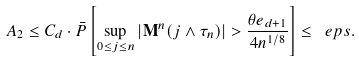Convert formula to latex. <formula><loc_0><loc_0><loc_500><loc_500>A _ { 2 } \leq C _ { d } \cdot \bar { P } \left [ \sup _ { 0 \leq j \leq n } | \mathbf M ^ { n } ( j \wedge \tau _ { n } ) | > \frac { \theta e _ { d + 1 } } { 4 n ^ { 1 / 8 } } \right ] \leq \ e p s .</formula> 